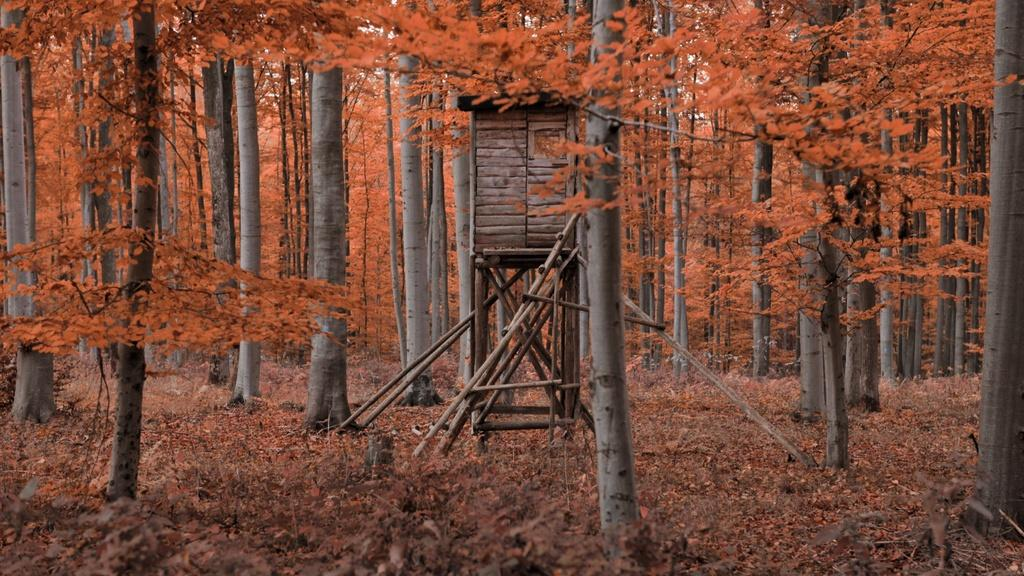What type of vegetation can be seen in the image? There are trees and grass in the image. What is on the ground in the image? There are leaves on the ground in the image. What structure is visible in the image? There is a wooden object that looks like a house in the image. Can you tell me how many friends are depicted in the image? There are no friends present in the image; it features trees, grass, leaves, and a wooden object that looks like a house. What type of lamp can be seen in the image? There is no lamp present in the image. 